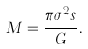Convert formula to latex. <formula><loc_0><loc_0><loc_500><loc_500>M = \frac { \pi \sigma ^ { 2 } s } { G } .</formula> 